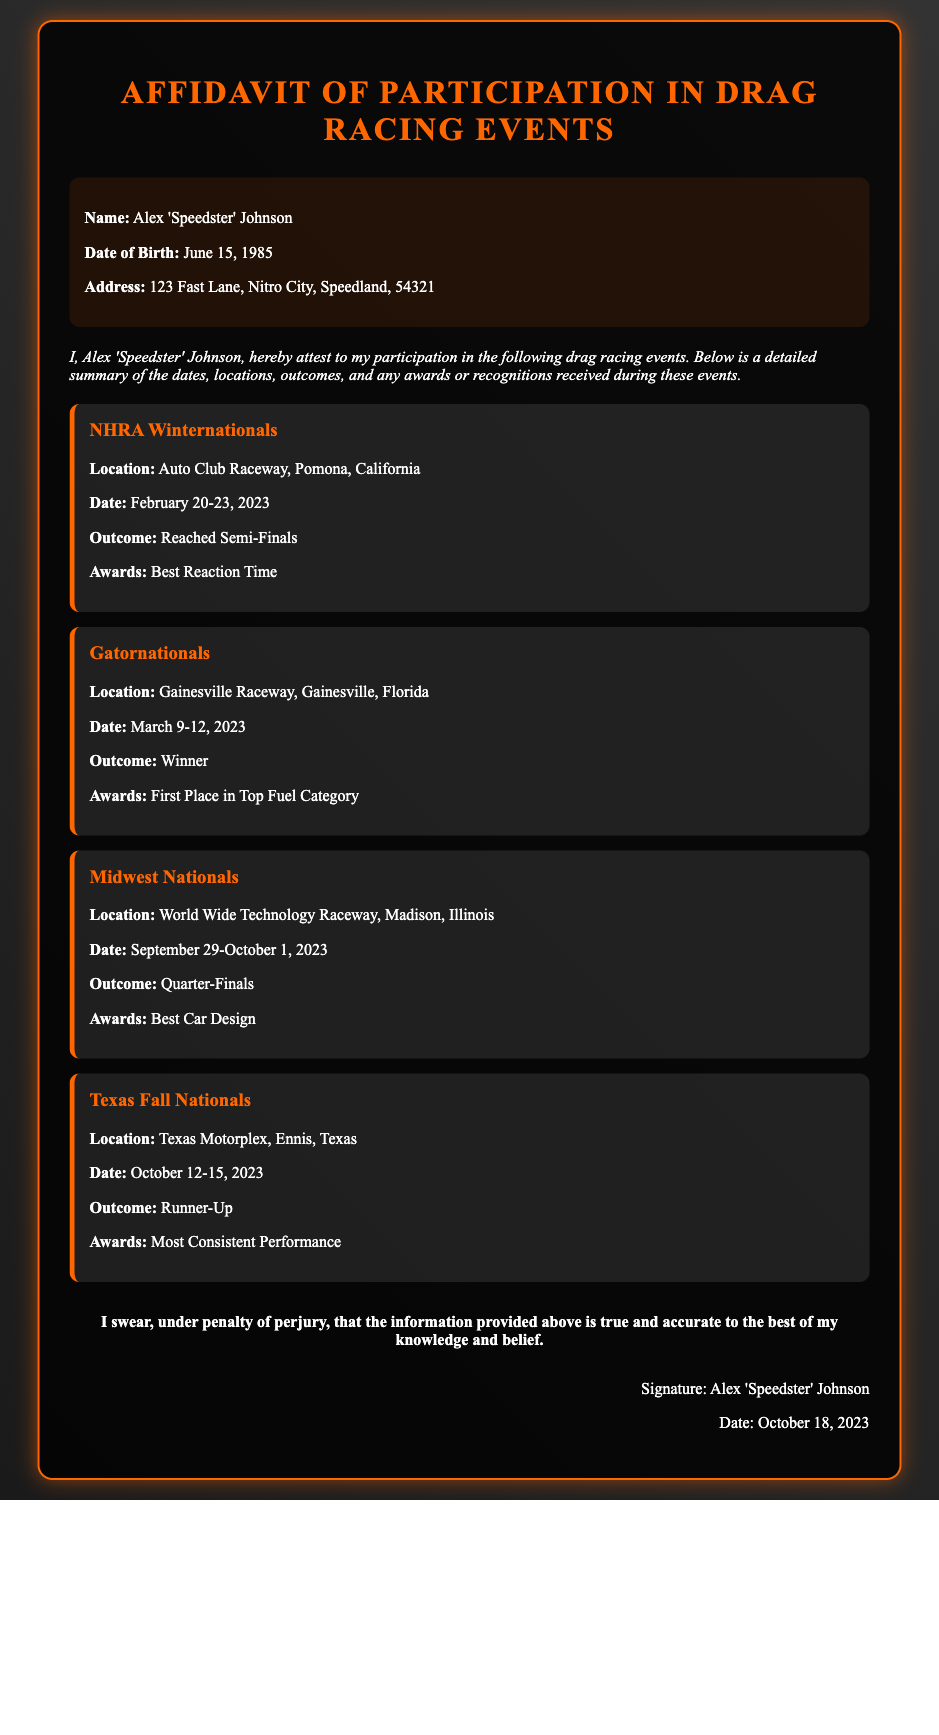What is the name of the participant? The participant's name is stated at the beginning of the document.
Answer: Alex 'Speedster' Johnson What was the location of the Gatornationals? The location is specified under the event details for the Gatornationals.
Answer: Gainesville Raceway, Gainesville, Florida What was the outcome of the Texas Fall Nationals? The outcome is listed under the Texas Fall Nationals event.
Answer: Runner-Up What award did Alex receive at the NHRA Winternationals? The award is noted in the event details for NHRA Winternationals.
Answer: Best Reaction Time On which date did the Midwest Nationals occur? The date of the event is provided directly under its details.
Answer: September 29-October 1, 2023 How many events are listed in the affidavit? The number of events can be counted from the event sections in the document.
Answer: Four What is the birth date of Alex 'Speedster' Johnson? The birth date is provided in the personal information section of the document.
Answer: June 15, 1985 Which award was received at the Midwest Nationals? The award given at the Midwest Nationals is mentioned under that event's details.
Answer: Best Car Design What does the affidavit state about the accuracy of the information? The affidavit includes a statement regarding the participant's belief in the accuracy of the information.
Answer: True and accurate 